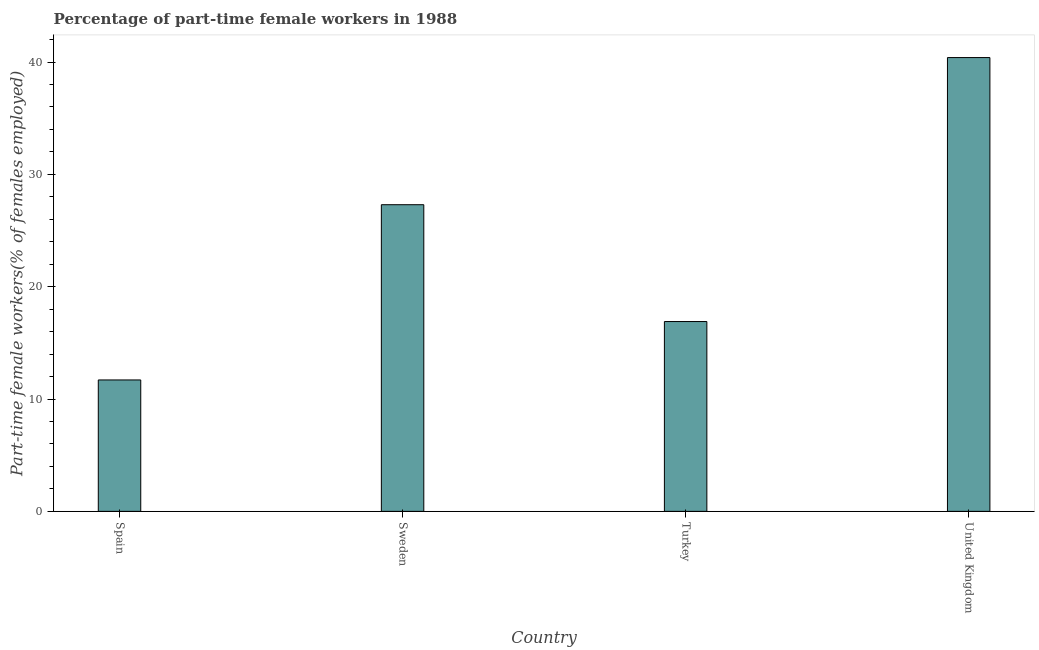Does the graph contain any zero values?
Make the answer very short. No. Does the graph contain grids?
Your answer should be compact. No. What is the title of the graph?
Make the answer very short. Percentage of part-time female workers in 1988. What is the label or title of the X-axis?
Your answer should be very brief. Country. What is the label or title of the Y-axis?
Your response must be concise. Part-time female workers(% of females employed). What is the percentage of part-time female workers in Turkey?
Offer a terse response. 16.9. Across all countries, what is the maximum percentage of part-time female workers?
Your answer should be very brief. 40.4. Across all countries, what is the minimum percentage of part-time female workers?
Offer a terse response. 11.7. In which country was the percentage of part-time female workers maximum?
Your answer should be compact. United Kingdom. What is the sum of the percentage of part-time female workers?
Ensure brevity in your answer.  96.3. What is the difference between the percentage of part-time female workers in Spain and Turkey?
Provide a short and direct response. -5.2. What is the average percentage of part-time female workers per country?
Your answer should be very brief. 24.07. What is the median percentage of part-time female workers?
Offer a very short reply. 22.1. In how many countries, is the percentage of part-time female workers greater than 14 %?
Offer a terse response. 3. What is the ratio of the percentage of part-time female workers in Sweden to that in Turkey?
Your answer should be very brief. 1.61. Is the percentage of part-time female workers in Spain less than that in Sweden?
Provide a succinct answer. Yes. What is the difference between the highest and the second highest percentage of part-time female workers?
Make the answer very short. 13.1. Is the sum of the percentage of part-time female workers in Spain and Sweden greater than the maximum percentage of part-time female workers across all countries?
Your answer should be compact. No. What is the difference between the highest and the lowest percentage of part-time female workers?
Make the answer very short. 28.7. In how many countries, is the percentage of part-time female workers greater than the average percentage of part-time female workers taken over all countries?
Your response must be concise. 2. How many bars are there?
Keep it short and to the point. 4. What is the Part-time female workers(% of females employed) of Spain?
Keep it short and to the point. 11.7. What is the Part-time female workers(% of females employed) of Sweden?
Make the answer very short. 27.3. What is the Part-time female workers(% of females employed) of Turkey?
Offer a very short reply. 16.9. What is the Part-time female workers(% of females employed) of United Kingdom?
Provide a succinct answer. 40.4. What is the difference between the Part-time female workers(% of females employed) in Spain and Sweden?
Ensure brevity in your answer.  -15.6. What is the difference between the Part-time female workers(% of females employed) in Spain and Turkey?
Your answer should be compact. -5.2. What is the difference between the Part-time female workers(% of females employed) in Spain and United Kingdom?
Ensure brevity in your answer.  -28.7. What is the difference between the Part-time female workers(% of females employed) in Turkey and United Kingdom?
Provide a short and direct response. -23.5. What is the ratio of the Part-time female workers(% of females employed) in Spain to that in Sweden?
Your response must be concise. 0.43. What is the ratio of the Part-time female workers(% of females employed) in Spain to that in Turkey?
Keep it short and to the point. 0.69. What is the ratio of the Part-time female workers(% of females employed) in Spain to that in United Kingdom?
Your answer should be compact. 0.29. What is the ratio of the Part-time female workers(% of females employed) in Sweden to that in Turkey?
Your answer should be very brief. 1.61. What is the ratio of the Part-time female workers(% of females employed) in Sweden to that in United Kingdom?
Your response must be concise. 0.68. What is the ratio of the Part-time female workers(% of females employed) in Turkey to that in United Kingdom?
Your response must be concise. 0.42. 